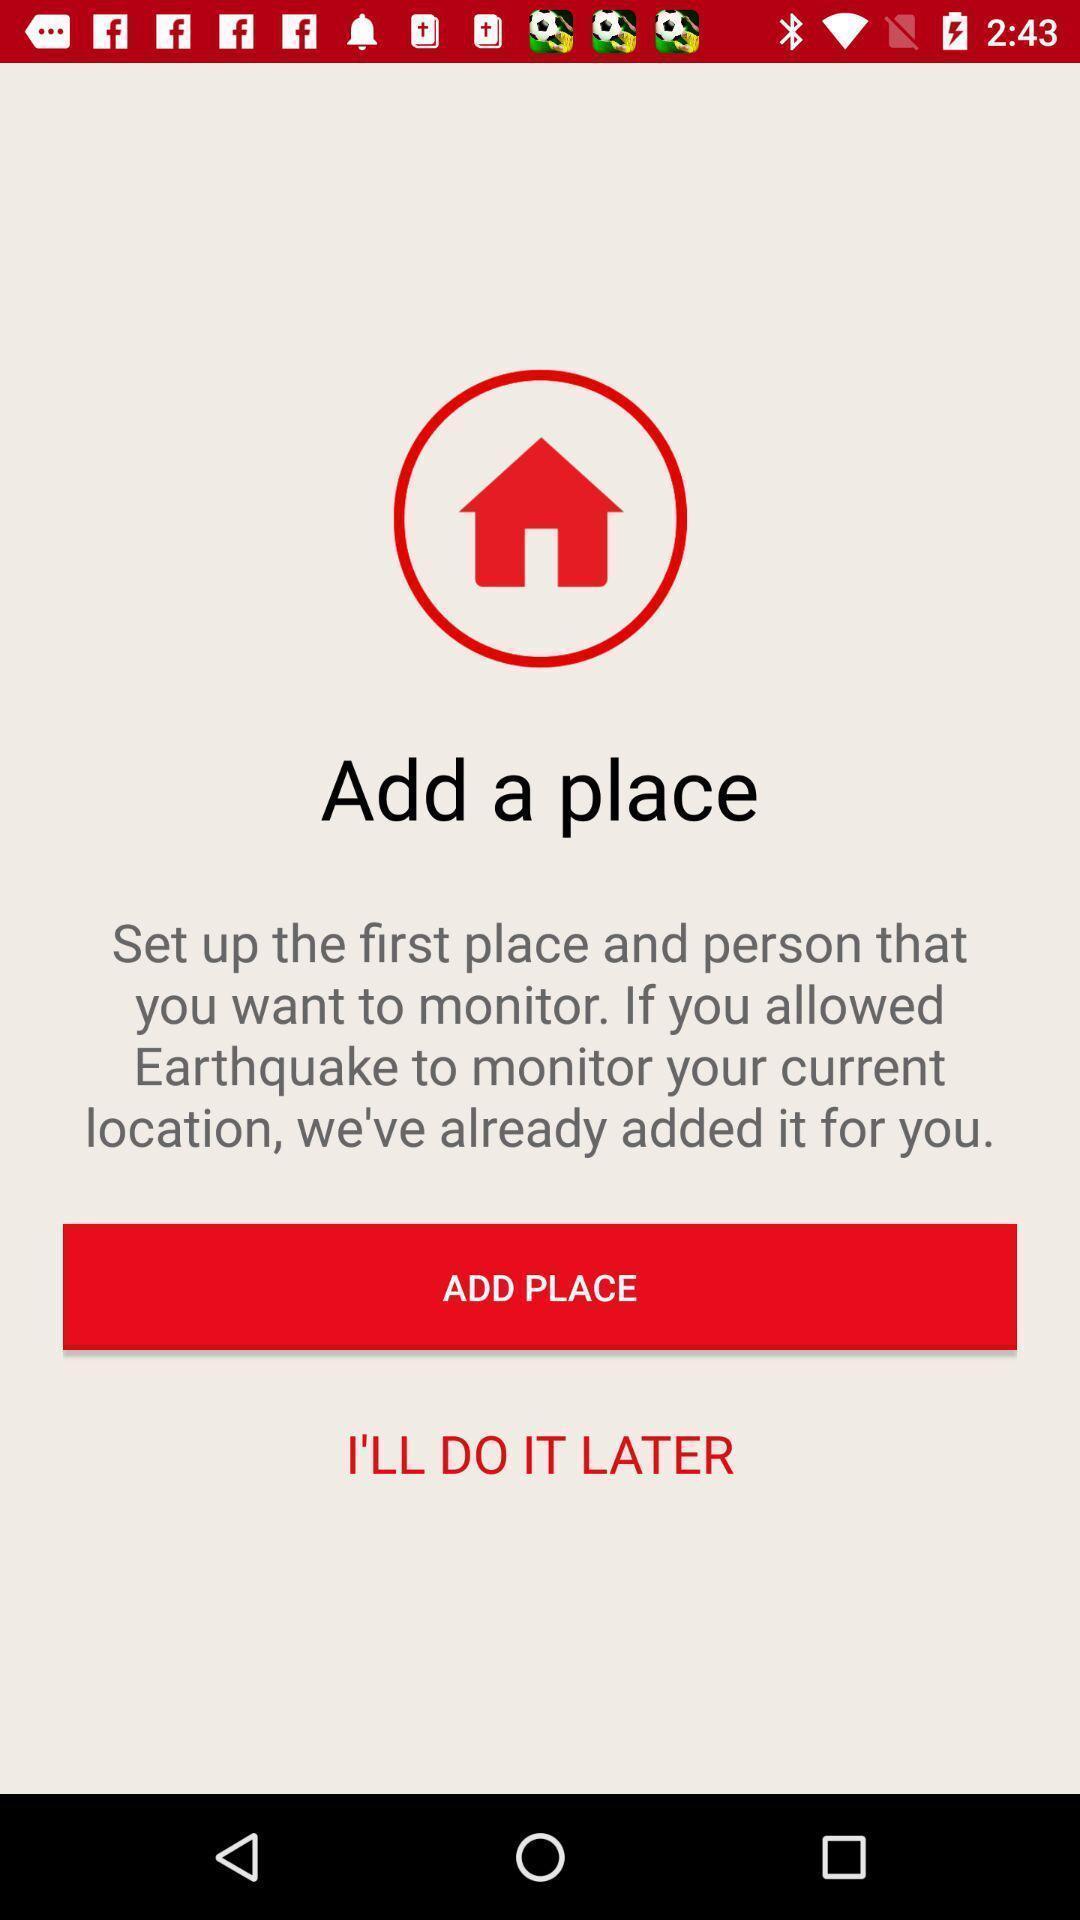Explain what's happening in this screen capture. Set up page with other option. 